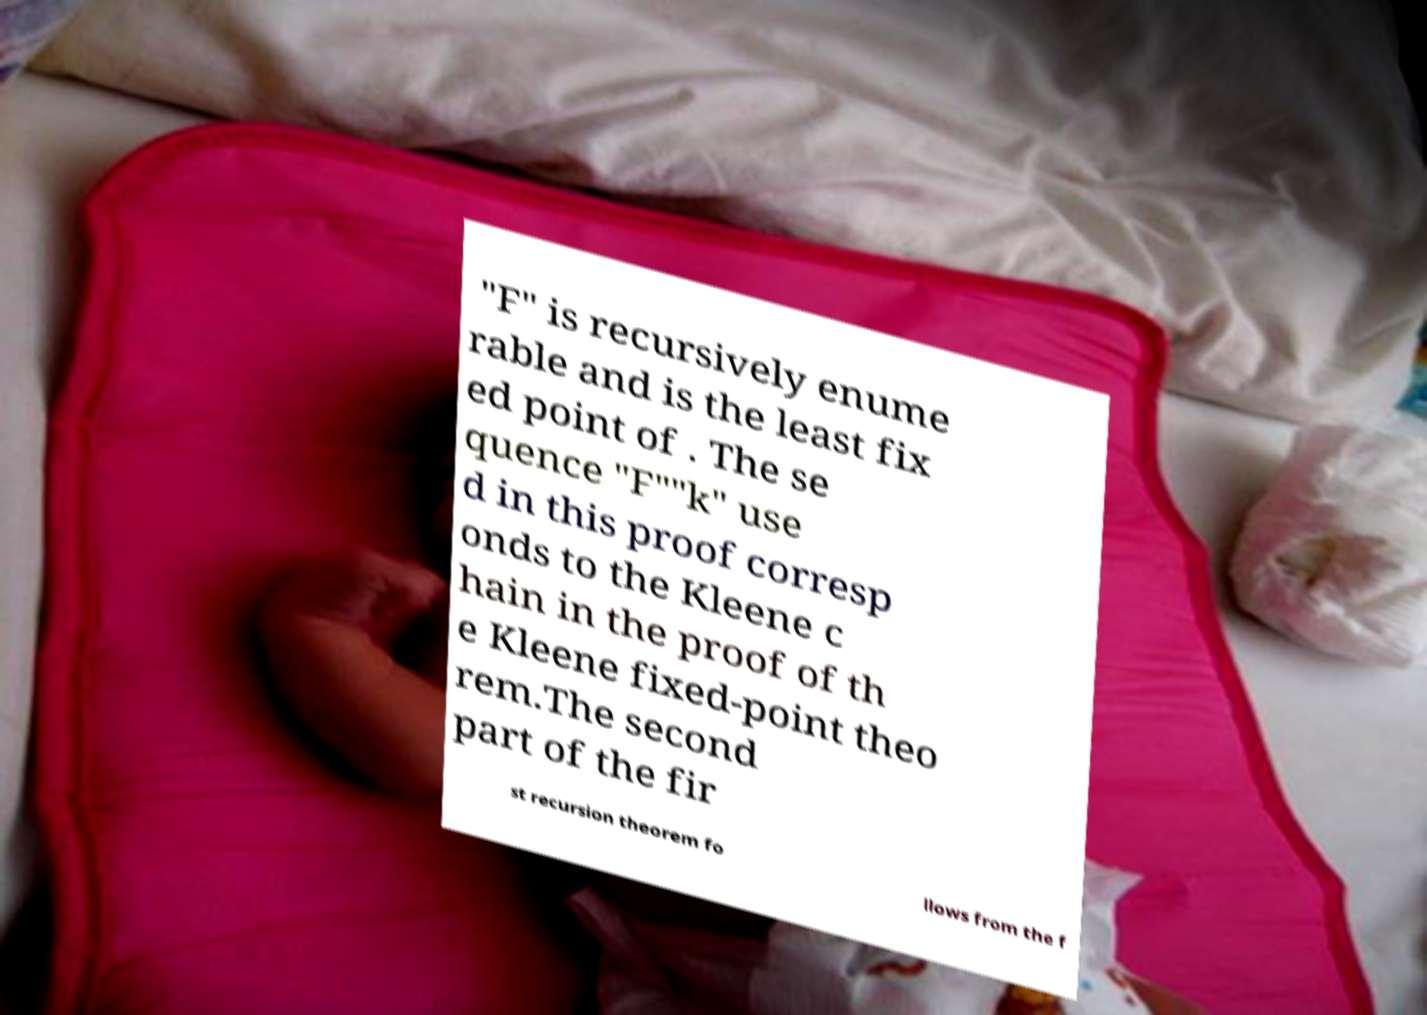Can you accurately transcribe the text from the provided image for me? "F" is recursively enume rable and is the least fix ed point of . The se quence "F""k" use d in this proof corresp onds to the Kleene c hain in the proof of th e Kleene fixed-point theo rem.The second part of the fir st recursion theorem fo llows from the f 